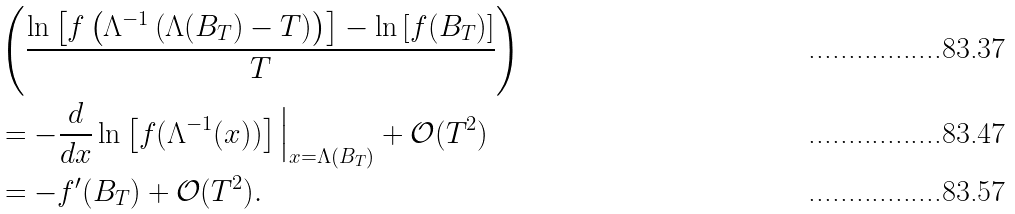Convert formula to latex. <formula><loc_0><loc_0><loc_500><loc_500>& \left ( \frac { \ln \left [ f \left ( \Lambda ^ { - 1 } \left ( \Lambda ( B _ { T } ) - T \right ) \right ) \right ] - \ln \left [ f ( B _ { T } ) \right ] } { T } \right ) \\ & = - \frac { d } { d x } \ln \left [ f ( \Lambda ^ { - 1 } ( x ) ) \right ] \Big | _ { x = \Lambda ( B _ { T } ) } + \mathcal { O } ( T ^ { 2 } ) \\ & = - f ^ { \prime } ( B _ { T } ) + \mathcal { O } ( T ^ { 2 } ) .</formula> 